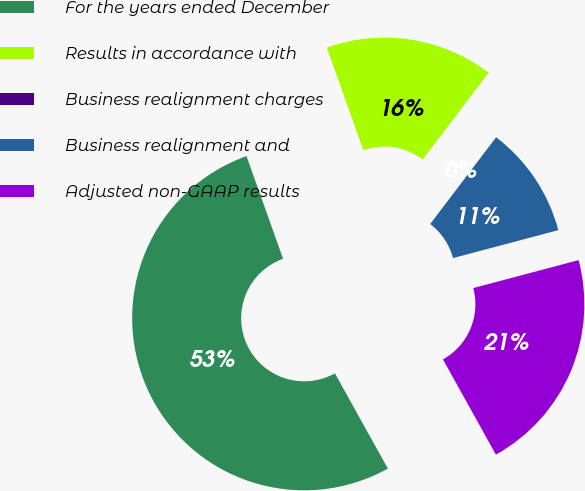<chart> <loc_0><loc_0><loc_500><loc_500><pie_chart><fcel>For the years ended December<fcel>Results in accordance with<fcel>Business realignment charges<fcel>Business realignment and<fcel>Adjusted non-GAAP results<nl><fcel>52.63%<fcel>15.79%<fcel>0.0%<fcel>10.53%<fcel>21.05%<nl></chart> 